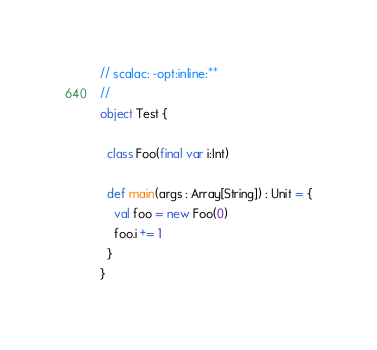<code> <loc_0><loc_0><loc_500><loc_500><_Scala_>// scalac: -opt:inline:**
//
object Test {

  class Foo(final var i:Int)

  def main(args : Array[String]) : Unit = {
  	val foo = new Foo(0)
  	foo.i += 1
  }
}
</code> 